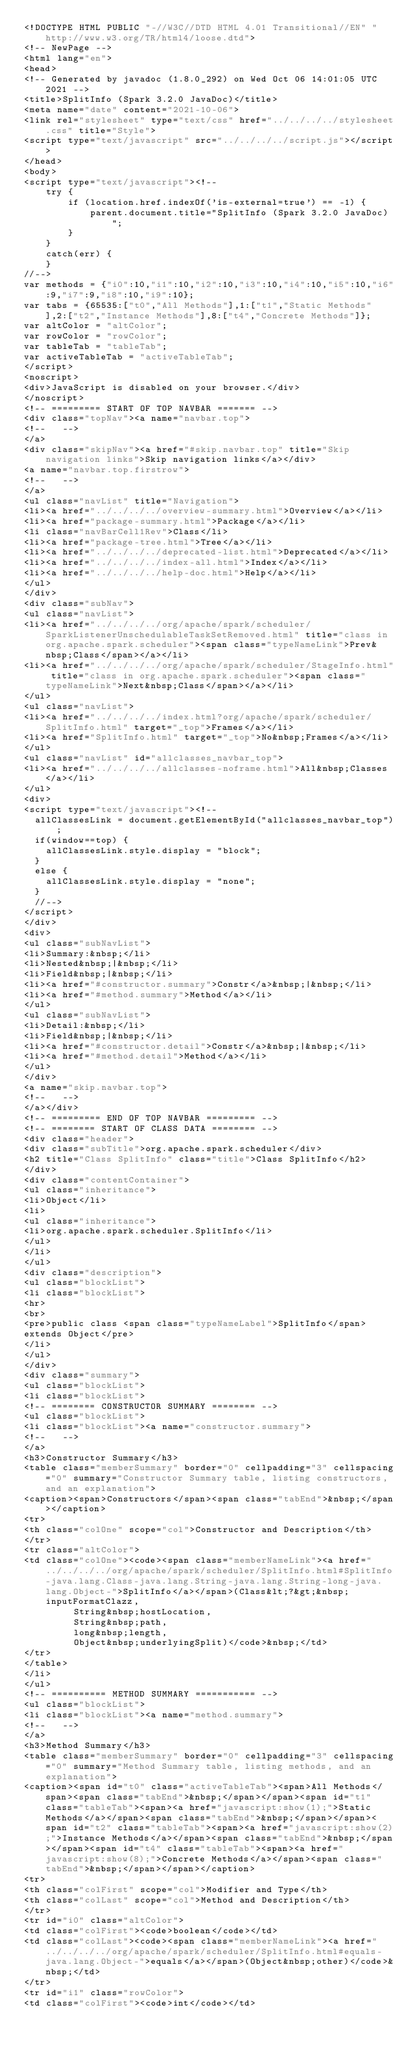Convert code to text. <code><loc_0><loc_0><loc_500><loc_500><_HTML_><!DOCTYPE HTML PUBLIC "-//W3C//DTD HTML 4.01 Transitional//EN" "http://www.w3.org/TR/html4/loose.dtd">
<!-- NewPage -->
<html lang="en">
<head>
<!-- Generated by javadoc (1.8.0_292) on Wed Oct 06 14:01:05 UTC 2021 -->
<title>SplitInfo (Spark 3.2.0 JavaDoc)</title>
<meta name="date" content="2021-10-06">
<link rel="stylesheet" type="text/css" href="../../../../stylesheet.css" title="Style">
<script type="text/javascript" src="../../../../script.js"></script>
</head>
<body>
<script type="text/javascript"><!--
    try {
        if (location.href.indexOf('is-external=true') == -1) {
            parent.document.title="SplitInfo (Spark 3.2.0 JavaDoc)";
        }
    }
    catch(err) {
    }
//-->
var methods = {"i0":10,"i1":10,"i2":10,"i3":10,"i4":10,"i5":10,"i6":9,"i7":9,"i8":10,"i9":10};
var tabs = {65535:["t0","All Methods"],1:["t1","Static Methods"],2:["t2","Instance Methods"],8:["t4","Concrete Methods"]};
var altColor = "altColor";
var rowColor = "rowColor";
var tableTab = "tableTab";
var activeTableTab = "activeTableTab";
</script>
<noscript>
<div>JavaScript is disabled on your browser.</div>
</noscript>
<!-- ========= START OF TOP NAVBAR ======= -->
<div class="topNav"><a name="navbar.top">
<!--   -->
</a>
<div class="skipNav"><a href="#skip.navbar.top" title="Skip navigation links">Skip navigation links</a></div>
<a name="navbar.top.firstrow">
<!--   -->
</a>
<ul class="navList" title="Navigation">
<li><a href="../../../../overview-summary.html">Overview</a></li>
<li><a href="package-summary.html">Package</a></li>
<li class="navBarCell1Rev">Class</li>
<li><a href="package-tree.html">Tree</a></li>
<li><a href="../../../../deprecated-list.html">Deprecated</a></li>
<li><a href="../../../../index-all.html">Index</a></li>
<li><a href="../../../../help-doc.html">Help</a></li>
</ul>
</div>
<div class="subNav">
<ul class="navList">
<li><a href="../../../../org/apache/spark/scheduler/SparkListenerUnschedulableTaskSetRemoved.html" title="class in org.apache.spark.scheduler"><span class="typeNameLink">Prev&nbsp;Class</span></a></li>
<li><a href="../../../../org/apache/spark/scheduler/StageInfo.html" title="class in org.apache.spark.scheduler"><span class="typeNameLink">Next&nbsp;Class</span></a></li>
</ul>
<ul class="navList">
<li><a href="../../../../index.html?org/apache/spark/scheduler/SplitInfo.html" target="_top">Frames</a></li>
<li><a href="SplitInfo.html" target="_top">No&nbsp;Frames</a></li>
</ul>
<ul class="navList" id="allclasses_navbar_top">
<li><a href="../../../../allclasses-noframe.html">All&nbsp;Classes</a></li>
</ul>
<div>
<script type="text/javascript"><!--
  allClassesLink = document.getElementById("allclasses_navbar_top");
  if(window==top) {
    allClassesLink.style.display = "block";
  }
  else {
    allClassesLink.style.display = "none";
  }
  //-->
</script>
</div>
<div>
<ul class="subNavList">
<li>Summary:&nbsp;</li>
<li>Nested&nbsp;|&nbsp;</li>
<li>Field&nbsp;|&nbsp;</li>
<li><a href="#constructor.summary">Constr</a>&nbsp;|&nbsp;</li>
<li><a href="#method.summary">Method</a></li>
</ul>
<ul class="subNavList">
<li>Detail:&nbsp;</li>
<li>Field&nbsp;|&nbsp;</li>
<li><a href="#constructor.detail">Constr</a>&nbsp;|&nbsp;</li>
<li><a href="#method.detail">Method</a></li>
</ul>
</div>
<a name="skip.navbar.top">
<!--   -->
</a></div>
<!-- ========= END OF TOP NAVBAR ========= -->
<!-- ======== START OF CLASS DATA ======== -->
<div class="header">
<div class="subTitle">org.apache.spark.scheduler</div>
<h2 title="Class SplitInfo" class="title">Class SplitInfo</h2>
</div>
<div class="contentContainer">
<ul class="inheritance">
<li>Object</li>
<li>
<ul class="inheritance">
<li>org.apache.spark.scheduler.SplitInfo</li>
</ul>
</li>
</ul>
<div class="description">
<ul class="blockList">
<li class="blockList">
<hr>
<br>
<pre>public class <span class="typeNameLabel">SplitInfo</span>
extends Object</pre>
</li>
</ul>
</div>
<div class="summary">
<ul class="blockList">
<li class="blockList">
<!-- ======== CONSTRUCTOR SUMMARY ======== -->
<ul class="blockList">
<li class="blockList"><a name="constructor.summary">
<!--   -->
</a>
<h3>Constructor Summary</h3>
<table class="memberSummary" border="0" cellpadding="3" cellspacing="0" summary="Constructor Summary table, listing constructors, and an explanation">
<caption><span>Constructors</span><span class="tabEnd">&nbsp;</span></caption>
<tr>
<th class="colOne" scope="col">Constructor and Description</th>
</tr>
<tr class="altColor">
<td class="colOne"><code><span class="memberNameLink"><a href="../../../../org/apache/spark/scheduler/SplitInfo.html#SplitInfo-java.lang.Class-java.lang.String-java.lang.String-long-java.lang.Object-">SplitInfo</a></span>(Class&lt;?&gt;&nbsp;inputFormatClazz,
         String&nbsp;hostLocation,
         String&nbsp;path,
         long&nbsp;length,
         Object&nbsp;underlyingSplit)</code>&nbsp;</td>
</tr>
</table>
</li>
</ul>
<!-- ========== METHOD SUMMARY =========== -->
<ul class="blockList">
<li class="blockList"><a name="method.summary">
<!--   -->
</a>
<h3>Method Summary</h3>
<table class="memberSummary" border="0" cellpadding="3" cellspacing="0" summary="Method Summary table, listing methods, and an explanation">
<caption><span id="t0" class="activeTableTab"><span>All Methods</span><span class="tabEnd">&nbsp;</span></span><span id="t1" class="tableTab"><span><a href="javascript:show(1);">Static Methods</a></span><span class="tabEnd">&nbsp;</span></span><span id="t2" class="tableTab"><span><a href="javascript:show(2);">Instance Methods</a></span><span class="tabEnd">&nbsp;</span></span><span id="t4" class="tableTab"><span><a href="javascript:show(8);">Concrete Methods</a></span><span class="tabEnd">&nbsp;</span></span></caption>
<tr>
<th class="colFirst" scope="col">Modifier and Type</th>
<th class="colLast" scope="col">Method and Description</th>
</tr>
<tr id="i0" class="altColor">
<td class="colFirst"><code>boolean</code></td>
<td class="colLast"><code><span class="memberNameLink"><a href="../../../../org/apache/spark/scheduler/SplitInfo.html#equals-java.lang.Object-">equals</a></span>(Object&nbsp;other)</code>&nbsp;</td>
</tr>
<tr id="i1" class="rowColor">
<td class="colFirst"><code>int</code></td></code> 